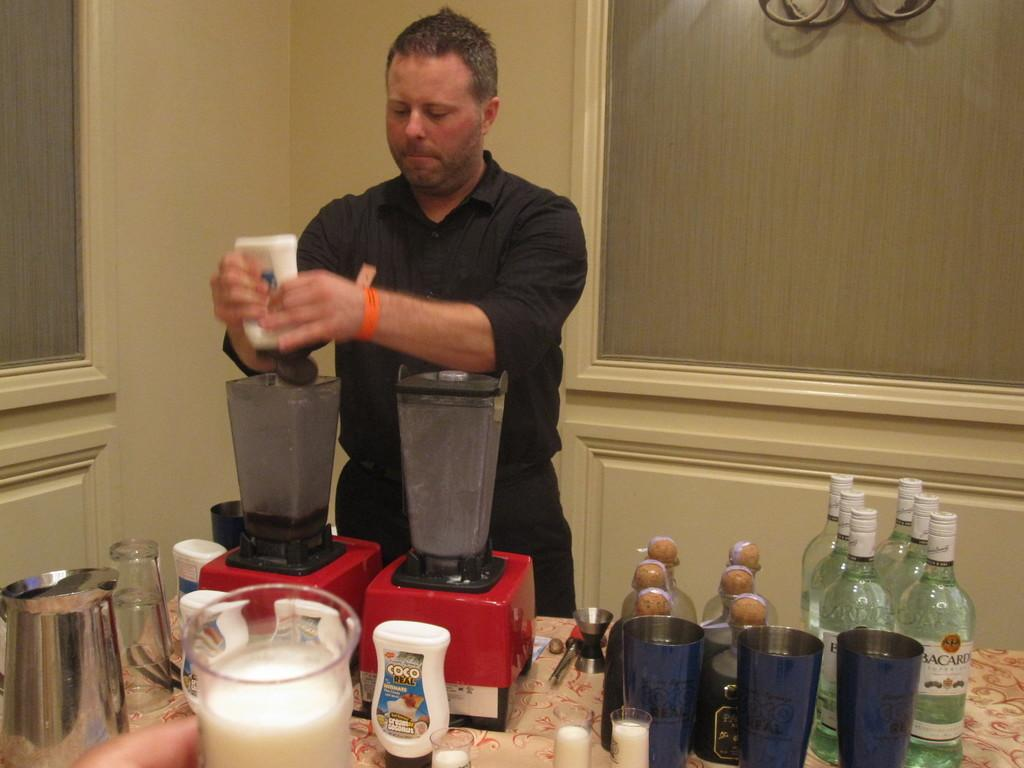What is the man in the image doing? The man is pouring something into a jar. What other objects are on the table in the image? There are bottles and glasses on the table. What is the jar being used for in the image? The jar is being filled with the substance the man is pouring. What can be seen in the background of the image? There is a wall visible in the background of the image. What type of wren can be seen perched on the jar in the image? There is no wren present in the image; it is a man pouring something into a jar. How many passengers are visible in the image? There are no passengers present in the image; it is a man performing an action with bottles, glasses, and a jar. 